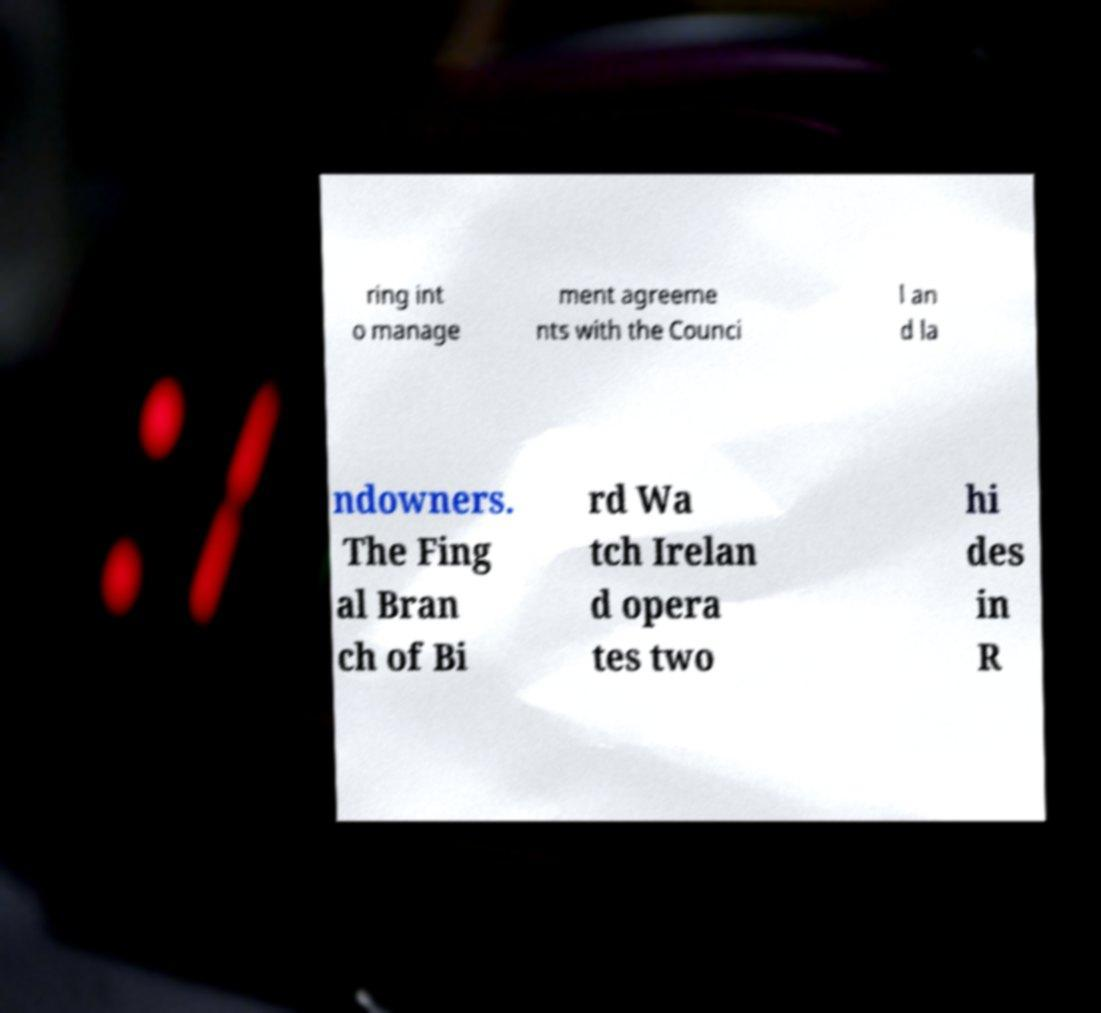Can you accurately transcribe the text from the provided image for me? ring int o manage ment agreeme nts with the Counci l an d la ndowners. The Fing al Bran ch of Bi rd Wa tch Irelan d opera tes two hi des in R 